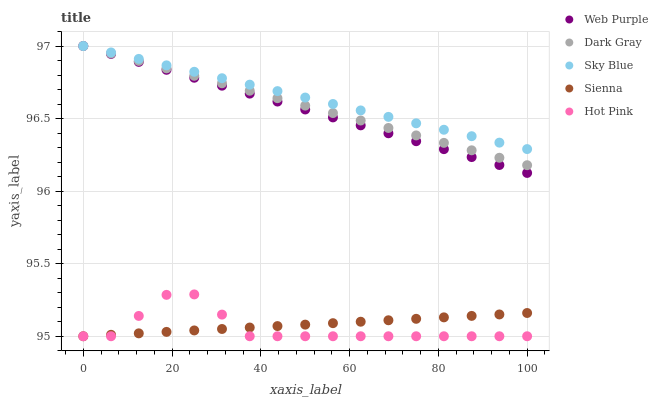Does Hot Pink have the minimum area under the curve?
Answer yes or no. Yes. Does Sky Blue have the maximum area under the curve?
Answer yes or no. Yes. Does Web Purple have the minimum area under the curve?
Answer yes or no. No. Does Web Purple have the maximum area under the curve?
Answer yes or no. No. Is Dark Gray the smoothest?
Answer yes or no. Yes. Is Hot Pink the roughest?
Answer yes or no. Yes. Is Sky Blue the smoothest?
Answer yes or no. No. Is Sky Blue the roughest?
Answer yes or no. No. Does Hot Pink have the lowest value?
Answer yes or no. Yes. Does Web Purple have the lowest value?
Answer yes or no. No. Does Web Purple have the highest value?
Answer yes or no. Yes. Does Hot Pink have the highest value?
Answer yes or no. No. Is Sienna less than Web Purple?
Answer yes or no. Yes. Is Web Purple greater than Hot Pink?
Answer yes or no. Yes. Does Sky Blue intersect Web Purple?
Answer yes or no. Yes. Is Sky Blue less than Web Purple?
Answer yes or no. No. Is Sky Blue greater than Web Purple?
Answer yes or no. No. Does Sienna intersect Web Purple?
Answer yes or no. No. 